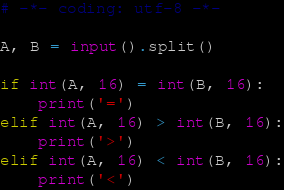Convert code to text. <code><loc_0><loc_0><loc_500><loc_500><_Python_># -*- coding: utf-8 -*-

A, B = input().split()

if int(A, 16) = int(B, 16):
    print('=')
elif int(A, 16) > int(B, 16):
    print('>')
elif int(A, 16) < int(B, 16):
    print('<')
</code> 